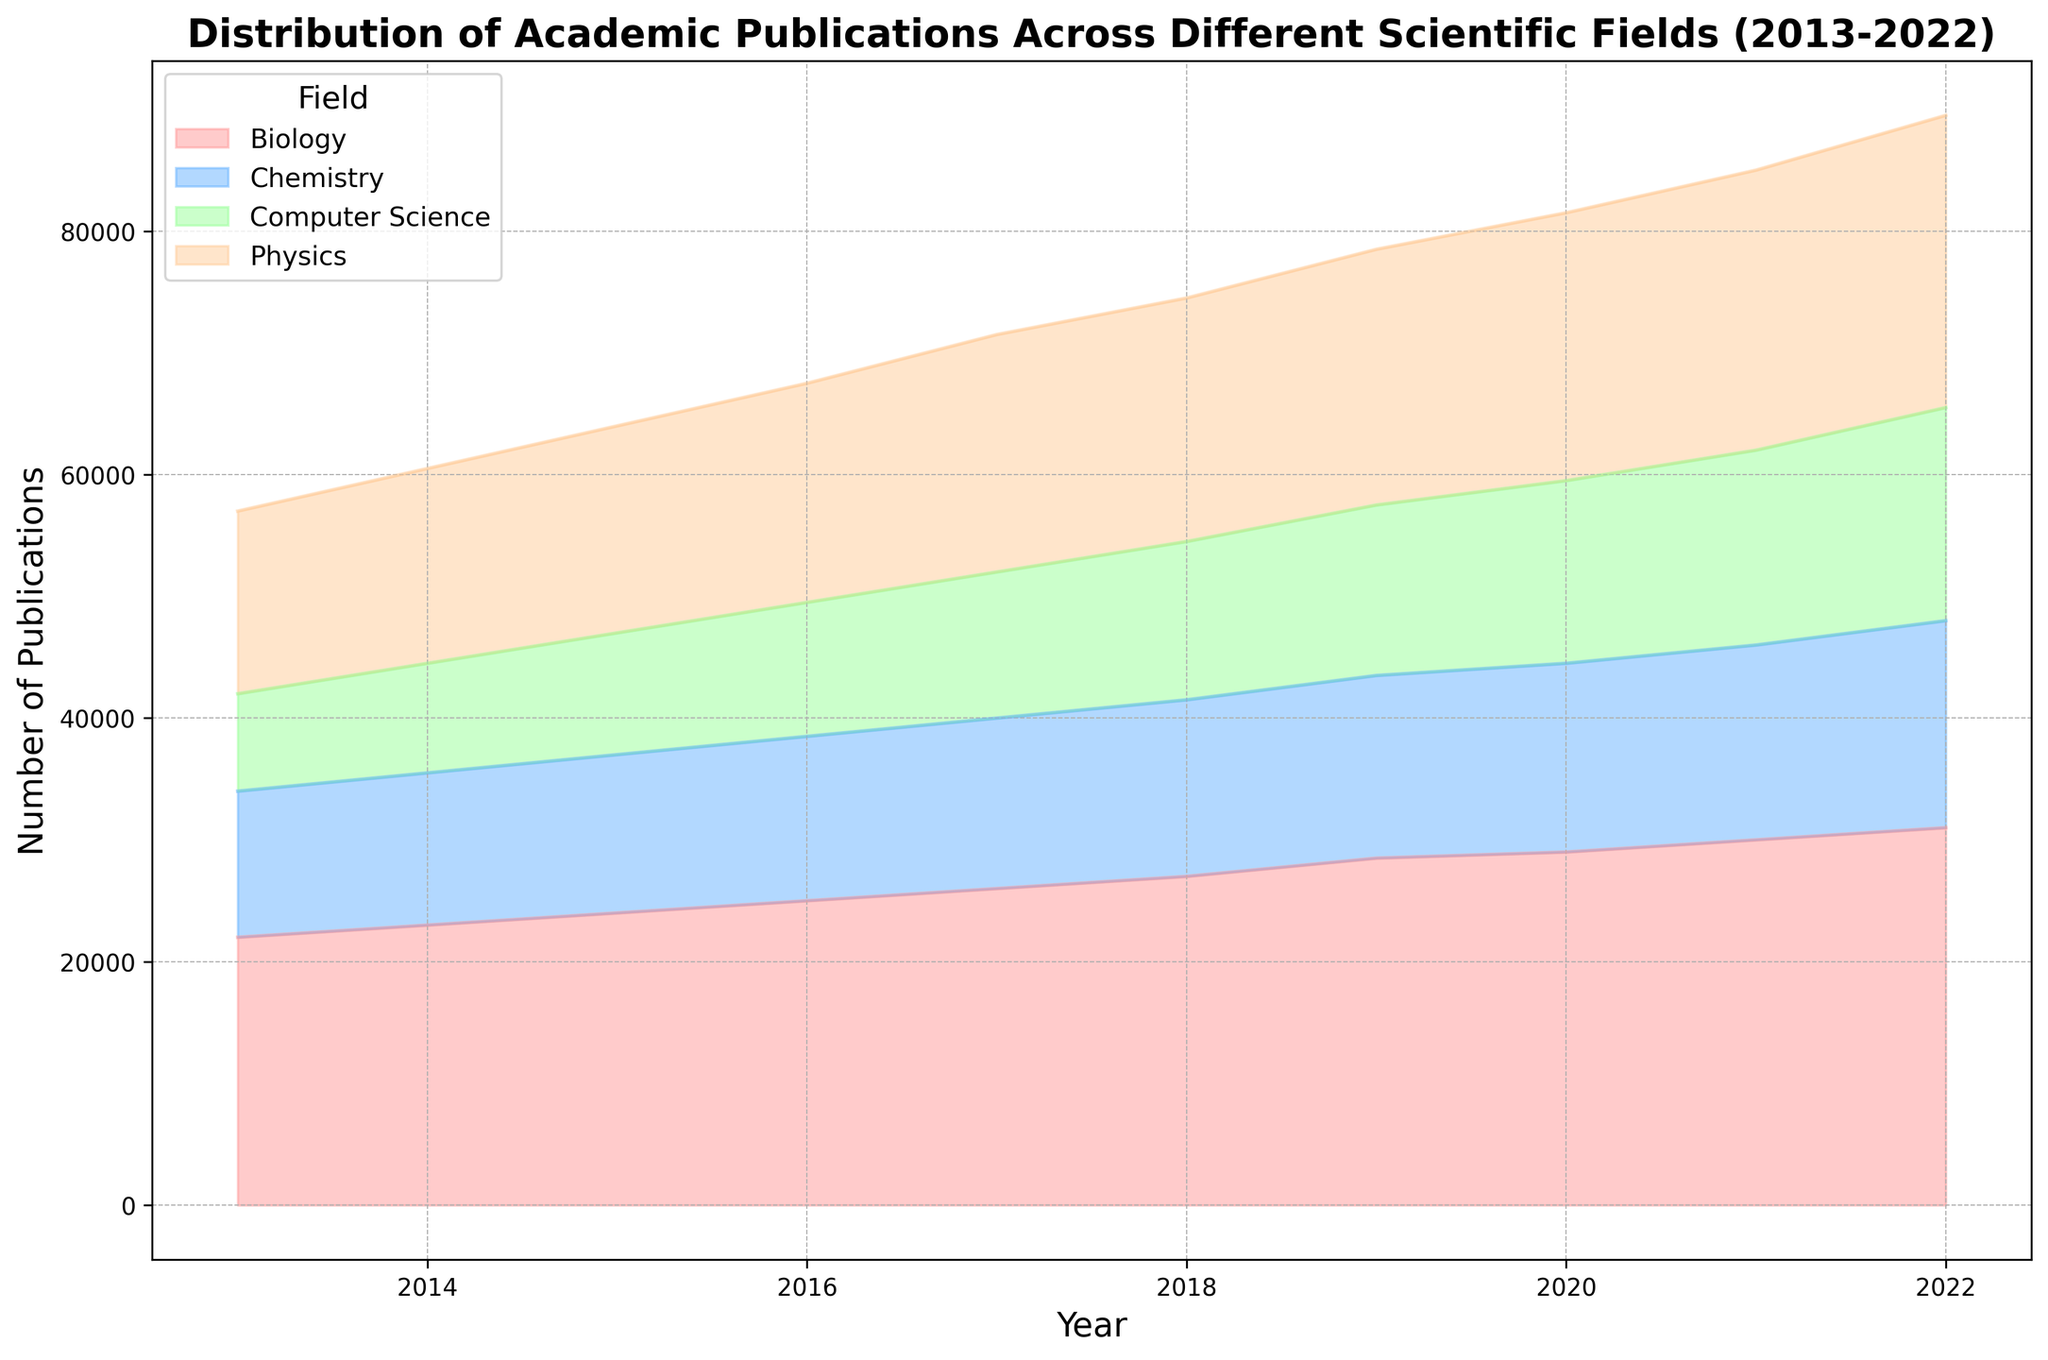What is the total number of publications in Biology in 2020 and 2022? The total number of publications in Biology in 2020 is 29,000, and in 2022 it is 31,000. Adding these gives 29,000 + 31,000 = 60,000.
Answer: 60,000 How did the number of publications in Chemistry change from 2013 to 2022? In 2013, Chemistry had 12,000 publications, and by 2022, this number increased to 17,000. Thus, the change is 17,000 - 12,000 = 5,000.
Answer: Increased by 5,000 Which field had the highest number of publications in 2018? From the figure, Biology had the highest number of publications in 2018 with 27,000 publications.
Answer: Biology Compare the total number of publications in Physics and Computer Science in 2022. Which one is higher and by how much? In 2022, Physics had 24,000 publications and Computer Science had 17,500 publications. Physics has 24,000 - 17,500 = 6,500 more publications than Computer Science.
Answer: Physics by 6,500 What is the average number of publications in Computer Science from 2013 to 2015? The number of publications in Computer Science from 2013 to 2015 are 8,000, 9,000, and 10,000 respectively. The average is (8,000 + 9,000 + 10,000) / 3 = 9,000.
Answer: 9,000 In which year did Biology surpass 25,000 publications for the first time? Examining the figure, Biology surpassed 25,000 publications for the first time in 2017 with 26,000 publications.
Answer: 2017 What is the difference in the number of publications between Physics and Chemistry in 2021? In 2021, Physics had 23,000 publications and Chemistry had 16,000 publications. The difference is 23,000 - 16,000 = 7,000.
Answer: 7,000 Which field had the least number of publications in 2016? From the figure, Computer Science had the least number of publications in 2016 with 11,000 publications.
Answer: Computer Science How does the total number of publications across all fields change from 2013 to 2022? The total number of publications in 2013 is 15,000 (Physics) + 12,000 (Chemistry) + 22,000 (Biology) + 8,000 (Computer Science) = 57,000. In 2022, the total is 24,000 (Physics) + 17,000 (Chemistry) + 31,000 (Biology) + 17,500 (Computer Science) = 89,500. The total change is 89,500 - 57,000 = 32,500.
Answer: Increased by 32,500 